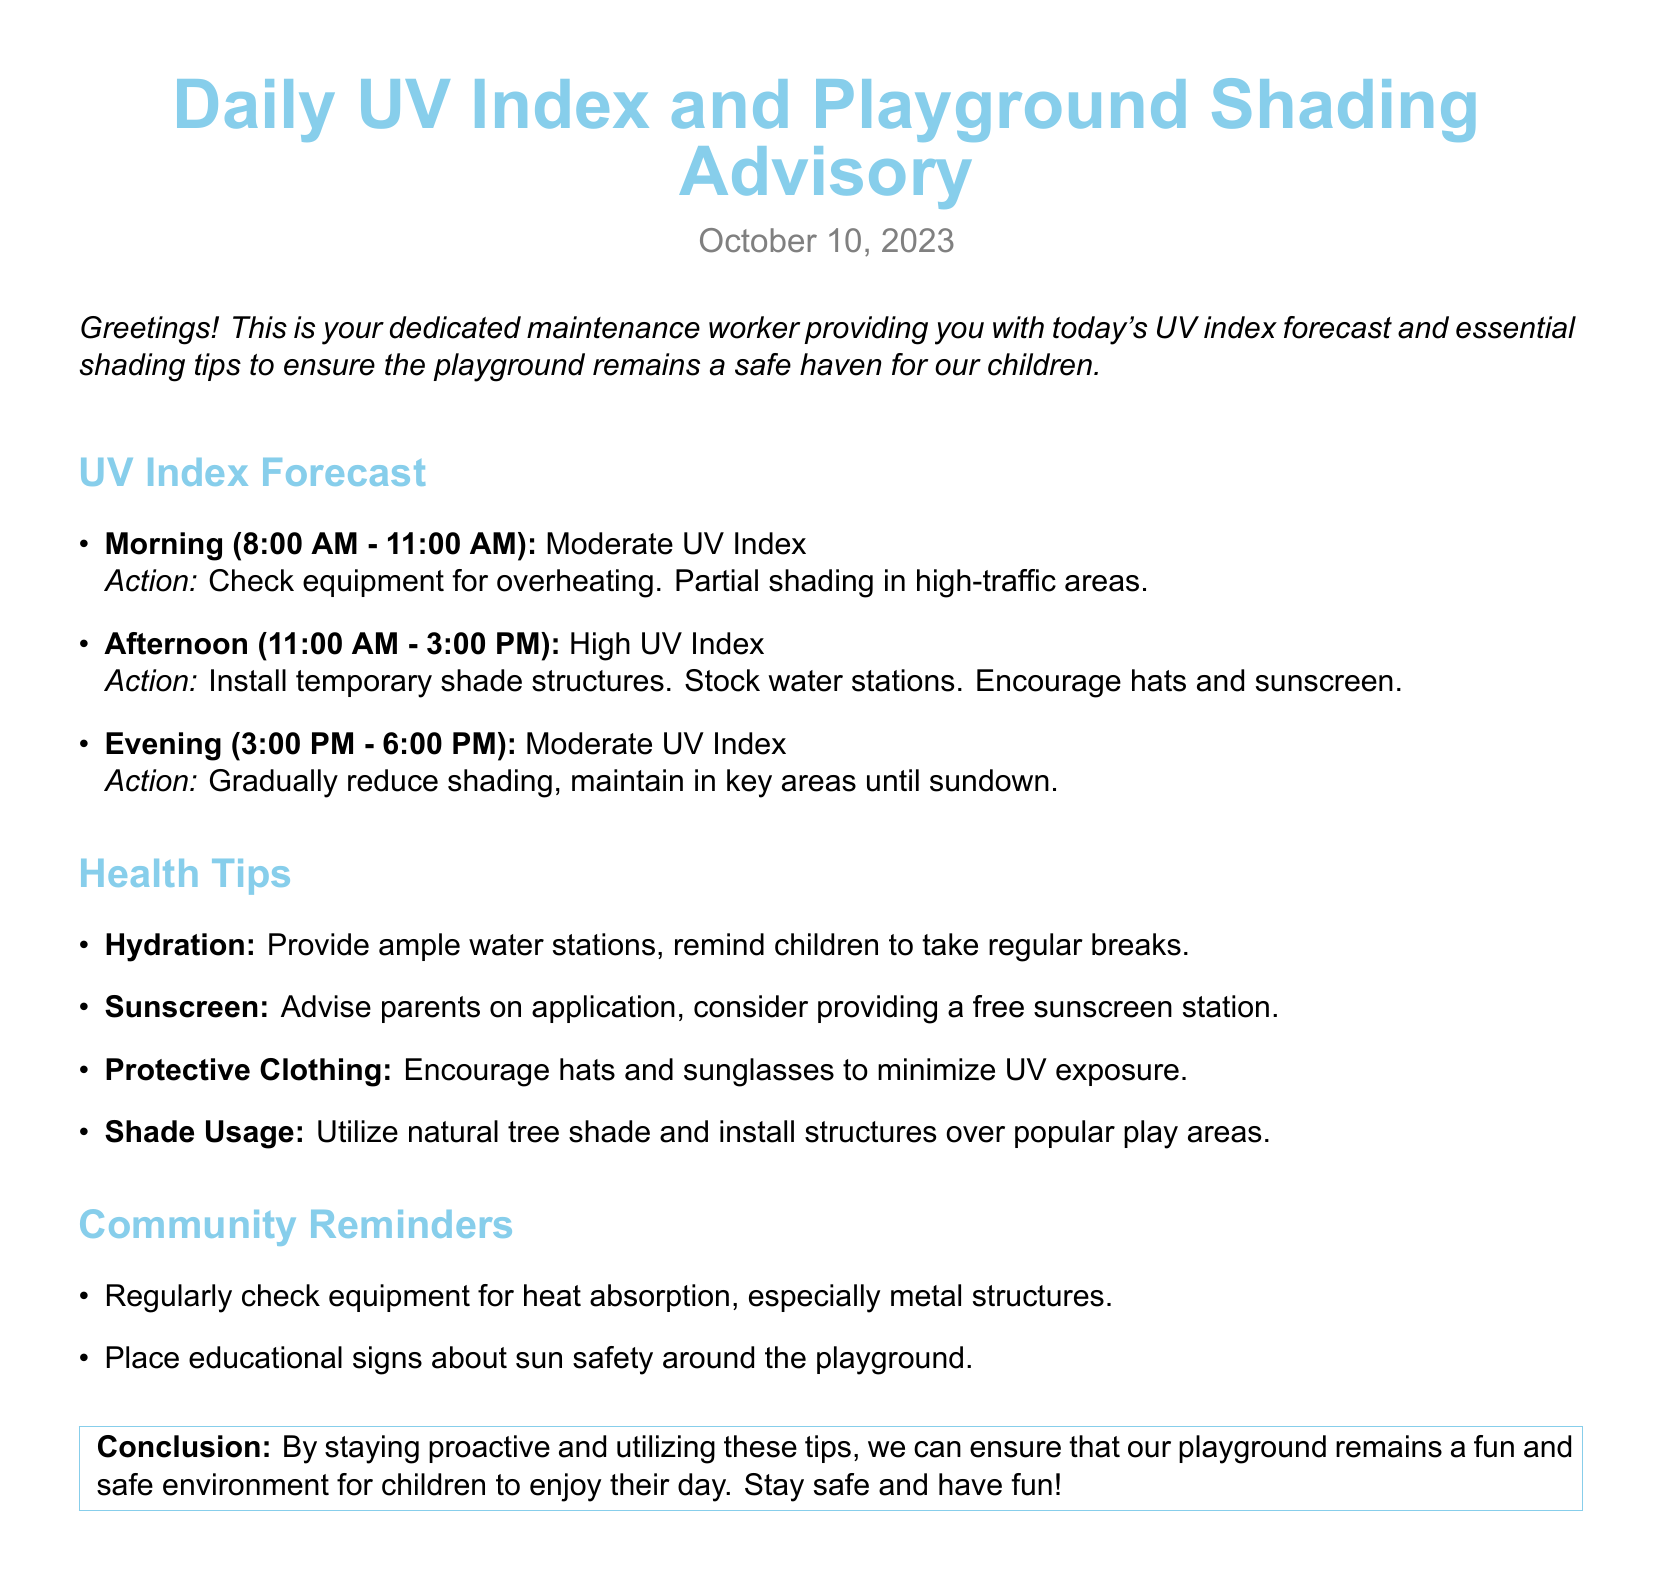What was the date of the report? The report is dated October 10, 2023, as mentioned in the document.
Answer: October 10, 2023 What time frame is considered for the afternoon UV index? The document specifies the afternoon UV index from 11:00 AM to 3:00 PM.
Answer: 11:00 AM - 3:00 PM What is the suggested action for the morning UV index? The document advises checking equipment for overheating and providing partial shading in high-traffic areas.
Answer: Check equipment for overheating What health tip suggests providing water stations? The hydration section emphasizes the importance of providing ample water stations for children.
Answer: Hydration What should be encouraged for children during high UV index times? The document mentions encouraging hats and sunscreen use during high UV index periods.
Answer: Hats and sunscreen How many UV index categories are mentioned in the report? The document outlines three UV index categories: morning, afternoon, and evening.
Answer: Three What is the recommended action for the evening UV index? The document advises gradually reducing shading while maintaining coverage in key areas until sundown.
Answer: Gradually reduce shading What is one community reminder mentioned? One of the reminders is to place educational signs about sun safety around the playground.
Answer: Educational signs about sun safety 